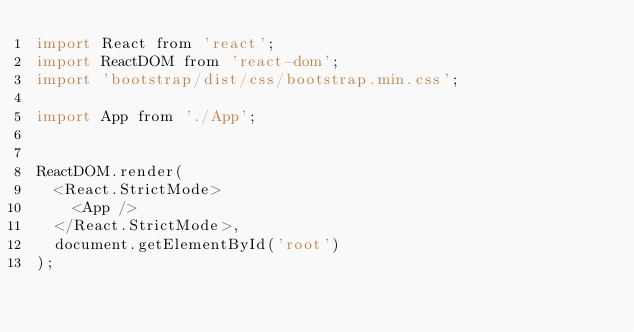Convert code to text. <code><loc_0><loc_0><loc_500><loc_500><_JavaScript_>import React from 'react';
import ReactDOM from 'react-dom';
import 'bootstrap/dist/css/bootstrap.min.css';

import App from './App';


ReactDOM.render(
  <React.StrictMode>
    <App />
  </React.StrictMode>,
  document.getElementById('root')
);


</code> 